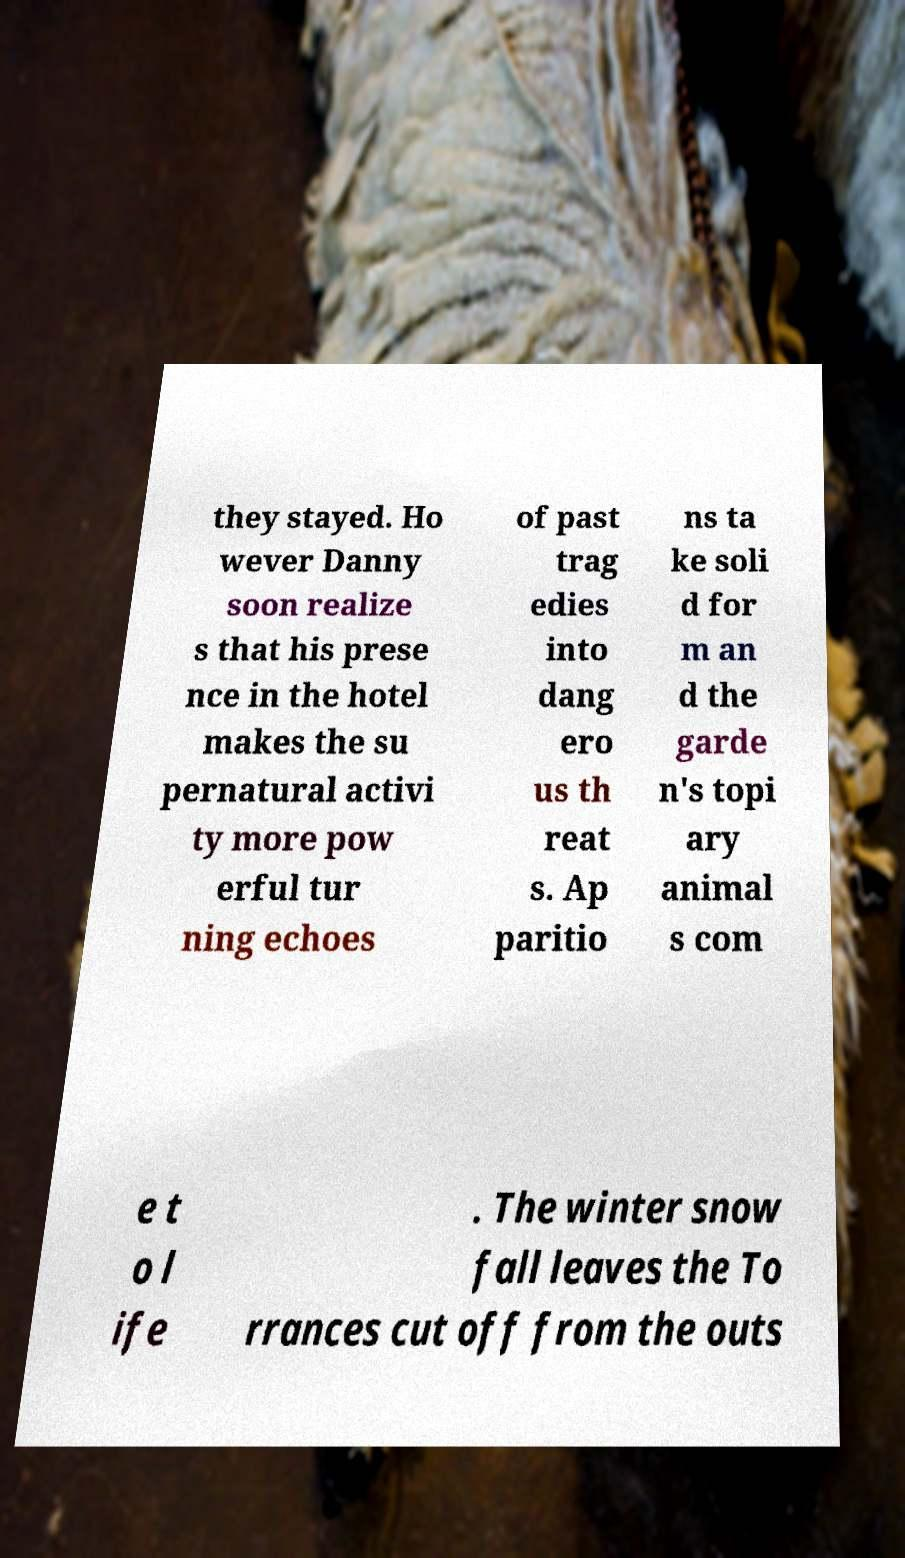Please identify and transcribe the text found in this image. they stayed. Ho wever Danny soon realize s that his prese nce in the hotel makes the su pernatural activi ty more pow erful tur ning echoes of past trag edies into dang ero us th reat s. Ap paritio ns ta ke soli d for m an d the garde n's topi ary animal s com e t o l ife . The winter snow fall leaves the To rrances cut off from the outs 